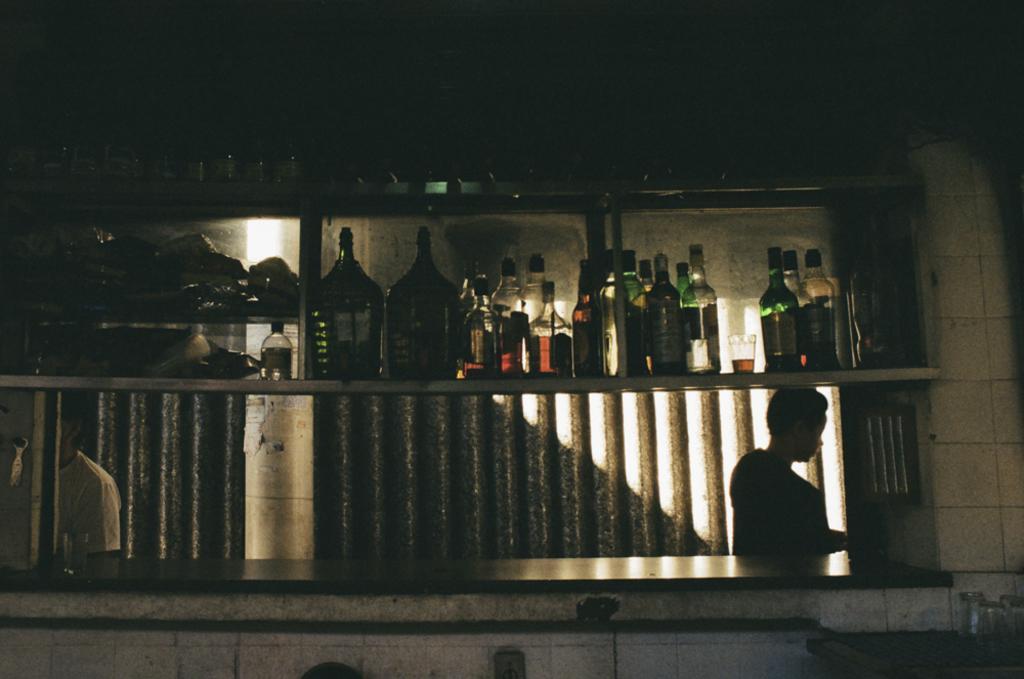Can you describe this image briefly? To the top side there is a cupboard with many bottle on it. And to the left side there is a man standing. And to the right side there is another man standing. And to the right bottom corner there is a table with glasses on it. 